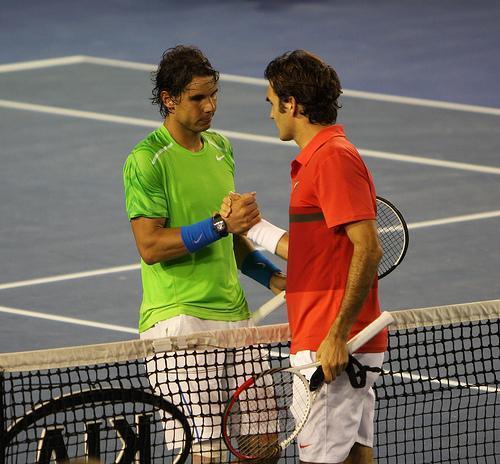How many men are there?
Give a very brief answer. 2. 